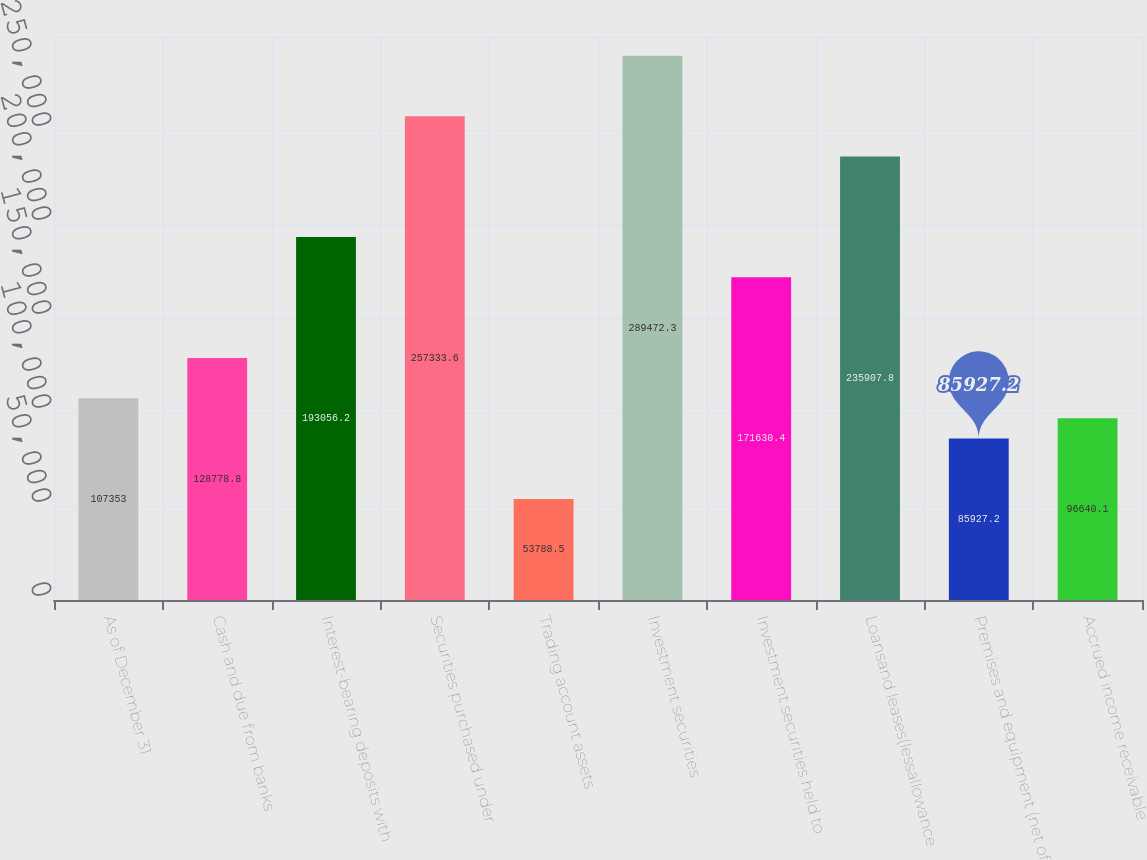Convert chart to OTSL. <chart><loc_0><loc_0><loc_500><loc_500><bar_chart><fcel>As of December 31<fcel>Cash and due from banks<fcel>Interest-bearing deposits with<fcel>Securities purchased under<fcel>Trading account assets<fcel>Investment securities<fcel>Investment securities held to<fcel>Loansand leases(lessallowance<fcel>Premises and equipment (net of<fcel>Accrued income receivable<nl><fcel>107353<fcel>128779<fcel>193056<fcel>257334<fcel>53788.5<fcel>289472<fcel>171630<fcel>235908<fcel>85927.2<fcel>96640.1<nl></chart> 